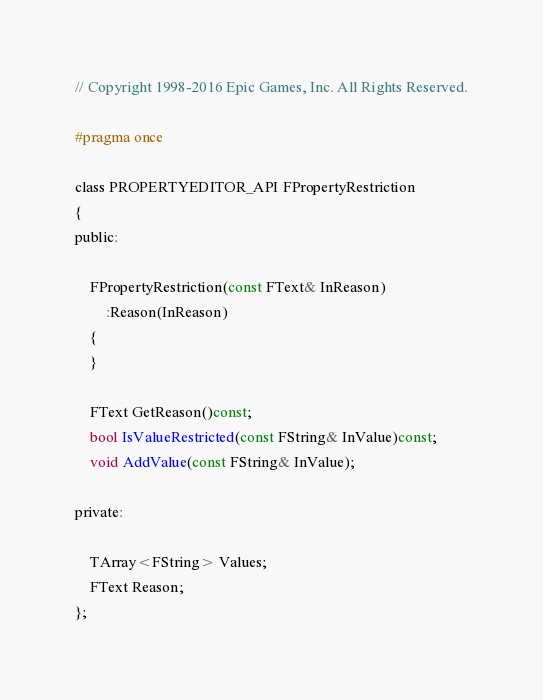<code> <loc_0><loc_0><loc_500><loc_500><_C_>// Copyright 1998-2016 Epic Games, Inc. All Rights Reserved.

#pragma once

class PROPERTYEDITOR_API FPropertyRestriction
{
public:
	
	FPropertyRestriction(const FText& InReason)
		:Reason(InReason)
	{
	}

	FText GetReason()const;
	bool IsValueRestricted(const FString& InValue)const;
	void AddValue(const FString& InValue);

private:

	TArray<FString> Values;
	FText Reason;
};
</code> 